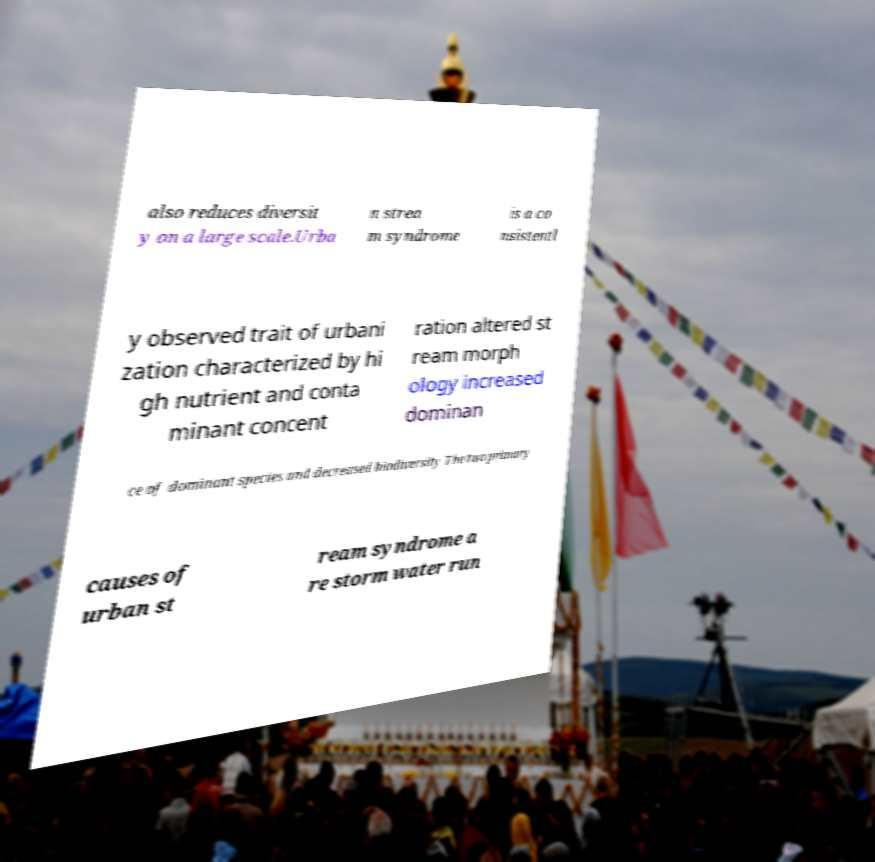There's text embedded in this image that I need extracted. Can you transcribe it verbatim? also reduces diversit y on a large scale.Urba n strea m syndrome is a co nsistentl y observed trait of urbani zation characterized by hi gh nutrient and conta minant concent ration altered st ream morph ology increased dominan ce of dominant species and decreased biodiversity The two primary causes of urban st ream syndrome a re storm water run 